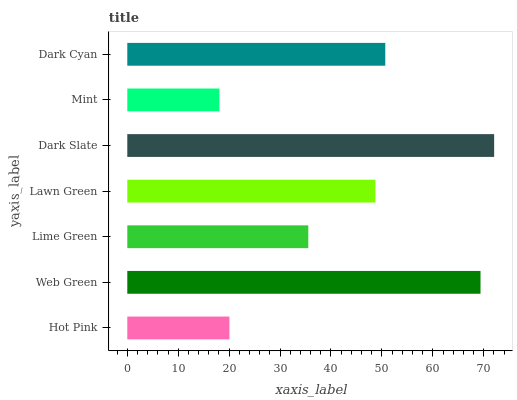Is Mint the minimum?
Answer yes or no. Yes. Is Dark Slate the maximum?
Answer yes or no. Yes. Is Web Green the minimum?
Answer yes or no. No. Is Web Green the maximum?
Answer yes or no. No. Is Web Green greater than Hot Pink?
Answer yes or no. Yes. Is Hot Pink less than Web Green?
Answer yes or no. Yes. Is Hot Pink greater than Web Green?
Answer yes or no. No. Is Web Green less than Hot Pink?
Answer yes or no. No. Is Lawn Green the high median?
Answer yes or no. Yes. Is Lawn Green the low median?
Answer yes or no. Yes. Is Lime Green the high median?
Answer yes or no. No. Is Mint the low median?
Answer yes or no. No. 